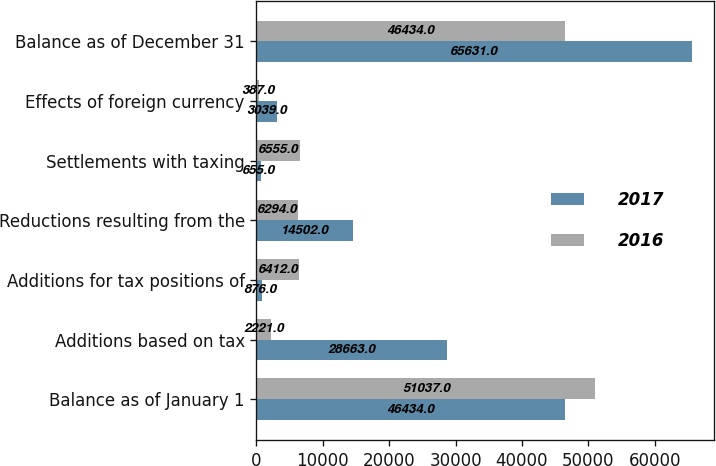Convert chart to OTSL. <chart><loc_0><loc_0><loc_500><loc_500><stacked_bar_chart><ecel><fcel>Balance as of January 1<fcel>Additions based on tax<fcel>Additions for tax positions of<fcel>Reductions resulting from the<fcel>Settlements with taxing<fcel>Effects of foreign currency<fcel>Balance as of December 31<nl><fcel>2017<fcel>46434<fcel>28663<fcel>876<fcel>14502<fcel>655<fcel>3039<fcel>65631<nl><fcel>2016<fcel>51037<fcel>2221<fcel>6412<fcel>6294<fcel>6555<fcel>387<fcel>46434<nl></chart> 